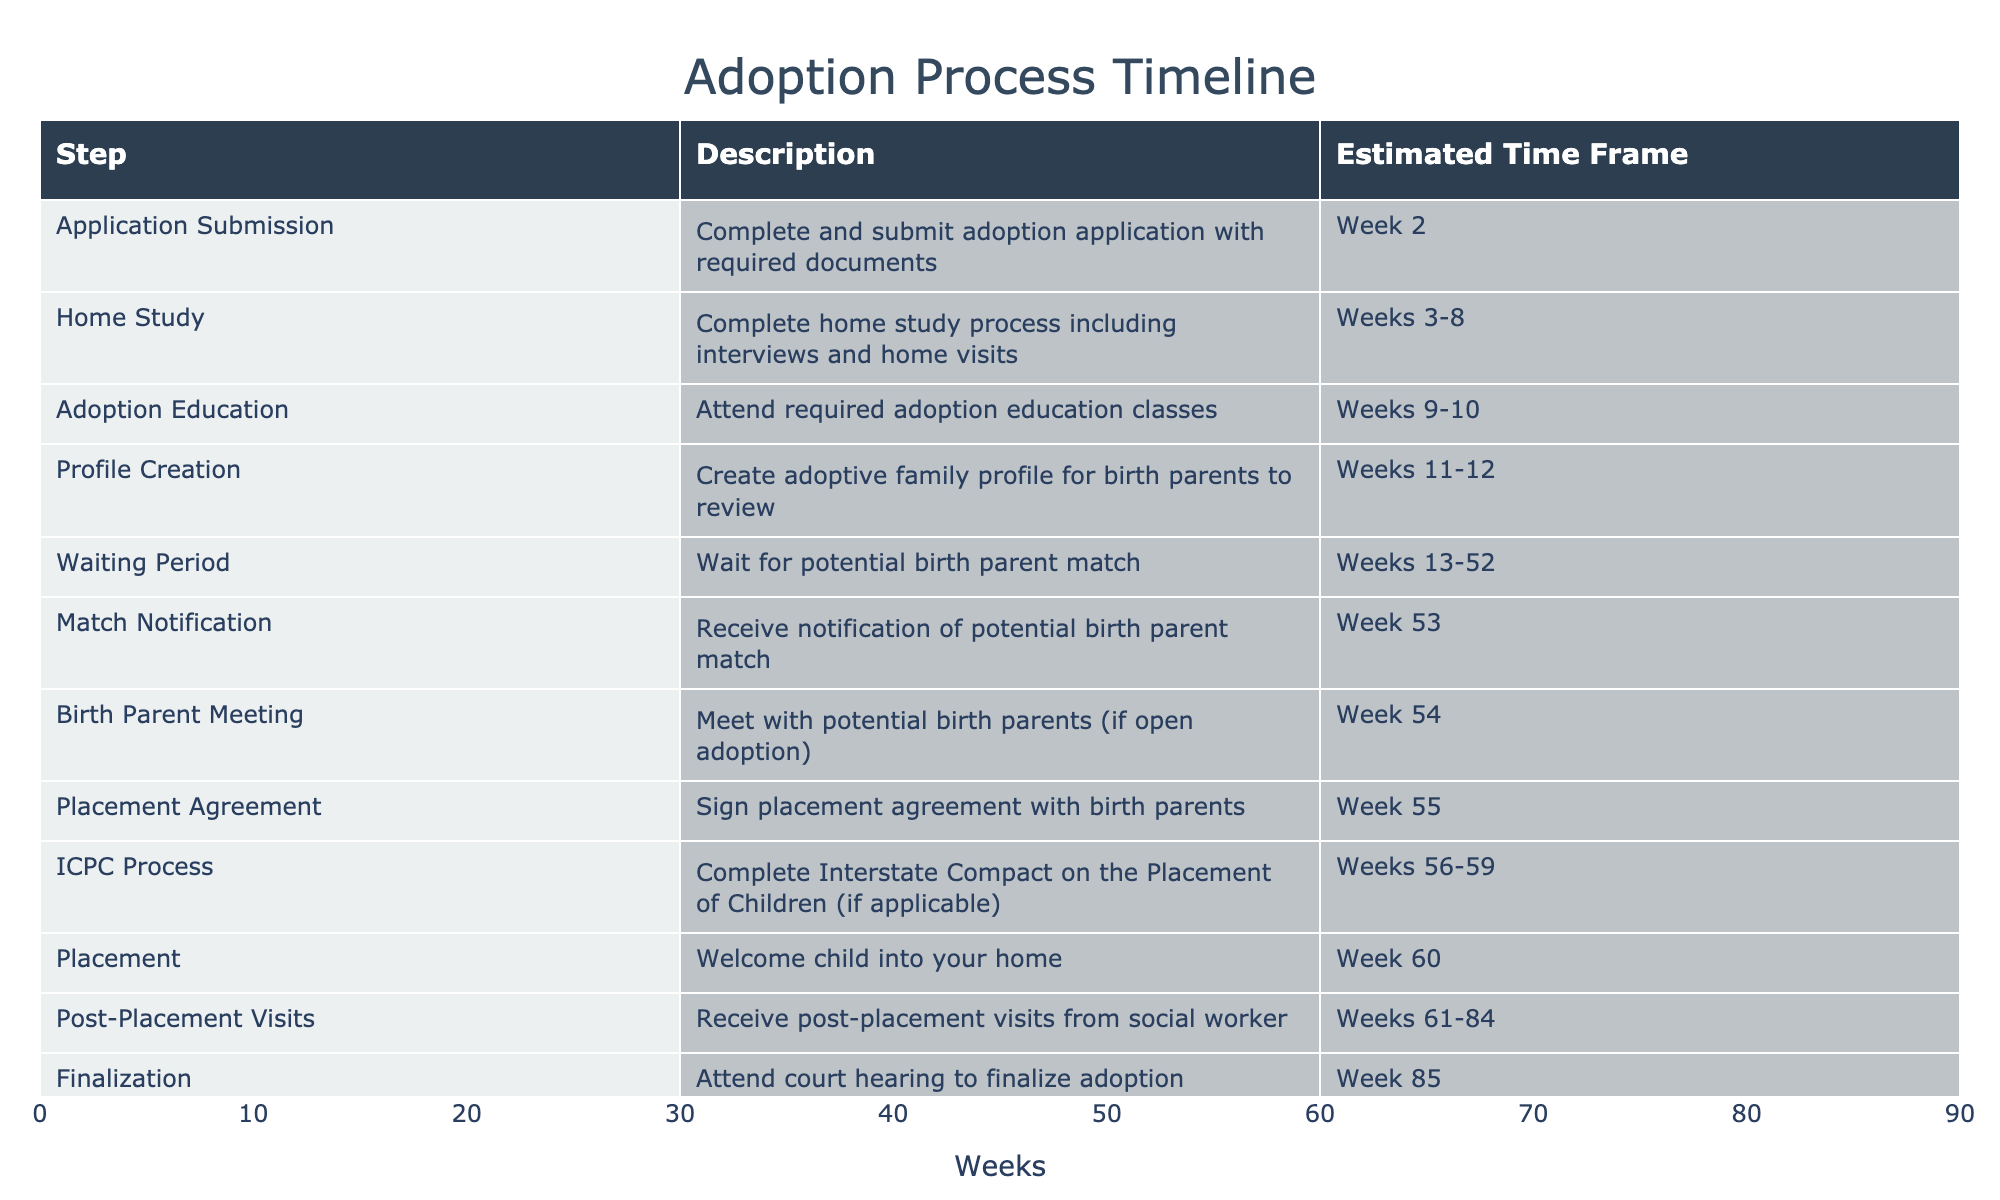What is the estimated time frame for the Home Study step? The table indicates that the Home Study process takes place from Weeks 3 to 8.
Answer: Weeks 3-8 How many weeks are allocated for the Waiting Period? The Waiting Period lasts from Week 13 to Week 52, which means it spans a total of 40 weeks (52 - 13 = 39, but including Week 13 means 40 weeks).
Answer: 40 weeks Is the Placement step supposed to occur before the Finalization step? According to the table, Placement occurs at Week 60, while Finalization takes place at Week 85. Since 60 is less than 85, Placement occurs before Finalization.
Answer: Yes What are the steps that occur after receiving a match notification? After the Match Notification at Week 53, the next steps are the Birth Parent Meeting at Week 54 and then signing the Placement Agreement at Week 55.
Answer: Birth Parent Meeting and Placement Agreement If the home study takes 6 weeks on average, how many weeks will it take in total to complete the home study process and the following adoption education? The Home Study spans Weeks 3 to 8 (6 weeks), and the Adoption Education takes Weeks 9 to 10 (2 weeks). Therefore, the total time from beginning the Home Study to finishing Adoption Education is 8 weeks total (Week 8) at completion of Home Study plus 2 weeks for Education, hence will take 10 weeks in total.
Answer: 10 weeks What step comes immediately after the Birth Parent Meeting? The step that comes immediately after the Birth Parent Meeting, which occurs in Week 54, is the Placement Agreement signing in Week 55.
Answer: Placement Agreement How long does the Post-Placement Visits step occur? The Post-Placement Visits are scheduled from Weeks 61 to 84, which totals 24 weeks (84 - 61 = 23, but including Week 61 means 24 weeks).
Answer: 24 weeks What is the total duration of the entire adoption process, from Application Submission to Finalization? The adoption process starts with Application Submission at Week 2 and concludes with Finalization at Week 85. This indicates the entire process takes 84 weeks (85 - 2 = 83, but since we include Week 2, it is 84 weeks in total).
Answer: 84 weeks 